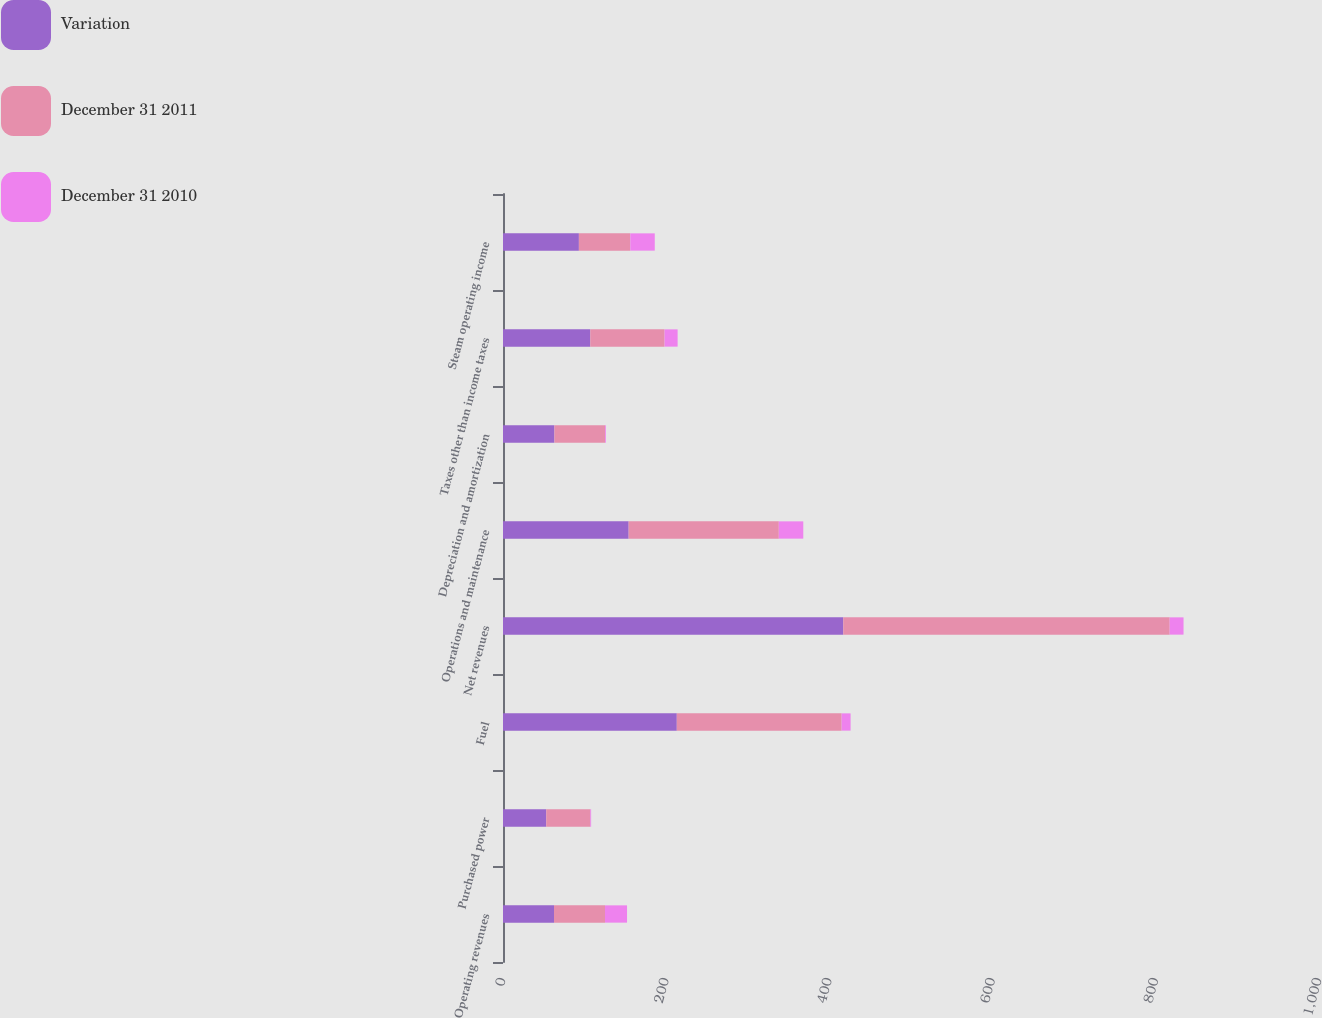Convert chart to OTSL. <chart><loc_0><loc_0><loc_500><loc_500><stacked_bar_chart><ecel><fcel>Operating revenues<fcel>Purchased power<fcel>Fuel<fcel>Net revenues<fcel>Operations and maintenance<fcel>Depreciation and amortization<fcel>Taxes other than income taxes<fcel>Steam operating income<nl><fcel>Variation<fcel>62.5<fcel>53<fcel>213<fcel>417<fcel>154<fcel>63<fcel>107<fcel>93<nl><fcel>December 31 2011<fcel>62.5<fcel>54<fcel>202<fcel>400<fcel>184<fcel>62<fcel>91<fcel>63<nl><fcel>December 31 2010<fcel>27<fcel>1<fcel>11<fcel>17<fcel>30<fcel>1<fcel>16<fcel>30<nl></chart> 